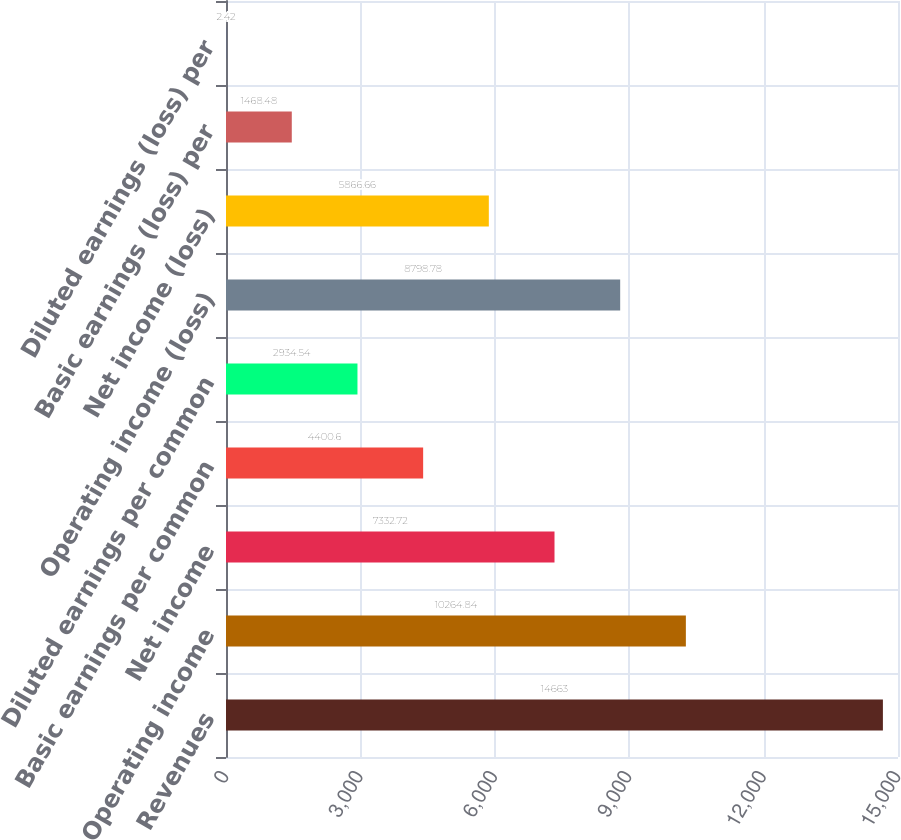Convert chart to OTSL. <chart><loc_0><loc_0><loc_500><loc_500><bar_chart><fcel>Revenues<fcel>Operating income<fcel>Net income<fcel>Basic earnings per common<fcel>Diluted earnings per common<fcel>Operating income (loss)<fcel>Net income (loss)<fcel>Basic earnings (loss) per<fcel>Diluted earnings (loss) per<nl><fcel>14663<fcel>10264.8<fcel>7332.72<fcel>4400.6<fcel>2934.54<fcel>8798.78<fcel>5866.66<fcel>1468.48<fcel>2.42<nl></chart> 